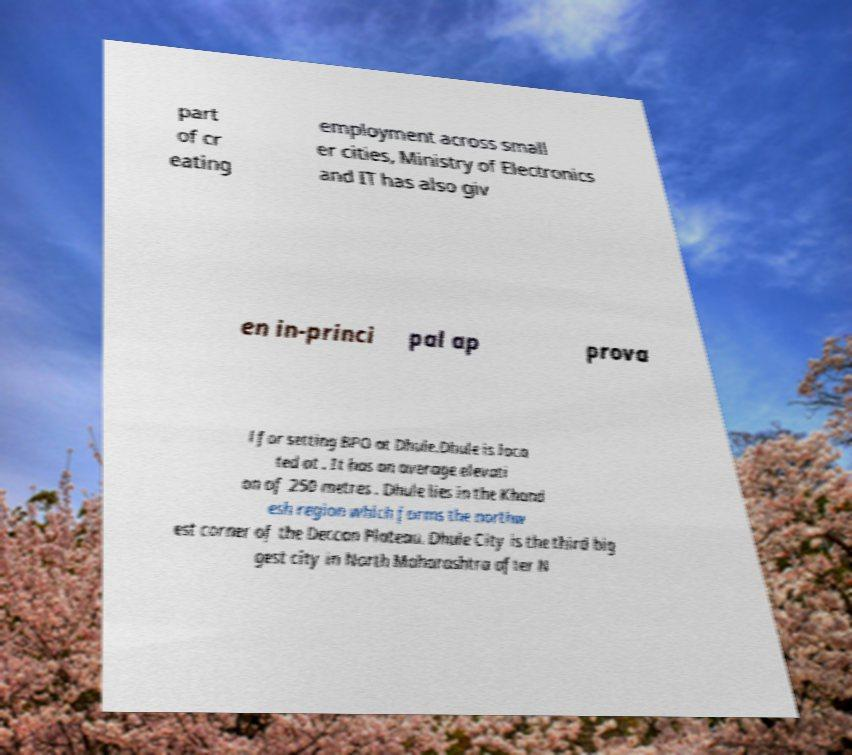Please read and relay the text visible in this image. What does it say? part of cr eating employment across small er cities, Ministry of Electronics and IT has also giv en in-princi pal ap prova l for setting BPO at Dhule.Dhule is loca ted at . It has an average elevati on of 250 metres . Dhule lies in the Khand esh region which forms the northw est corner of the Deccan Plateau. Dhule City is the third big gest city in North Maharashtra after N 